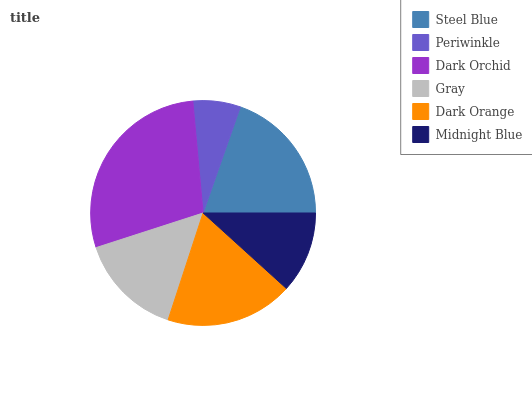Is Periwinkle the minimum?
Answer yes or no. Yes. Is Dark Orchid the maximum?
Answer yes or no. Yes. Is Dark Orchid the minimum?
Answer yes or no. No. Is Periwinkle the maximum?
Answer yes or no. No. Is Dark Orchid greater than Periwinkle?
Answer yes or no. Yes. Is Periwinkle less than Dark Orchid?
Answer yes or no. Yes. Is Periwinkle greater than Dark Orchid?
Answer yes or no. No. Is Dark Orchid less than Periwinkle?
Answer yes or no. No. Is Dark Orange the high median?
Answer yes or no. Yes. Is Gray the low median?
Answer yes or no. Yes. Is Steel Blue the high median?
Answer yes or no. No. Is Dark Orchid the low median?
Answer yes or no. No. 